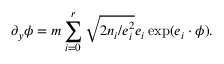<formula> <loc_0><loc_0><loc_500><loc_500>\partial _ { y } \phi = m \sum _ { i = 0 } ^ { r } \sqrt { 2 n _ { i } / e _ { i } ^ { 2 } } e _ { i } \exp ( e _ { i } \cdot \phi ) .</formula> 